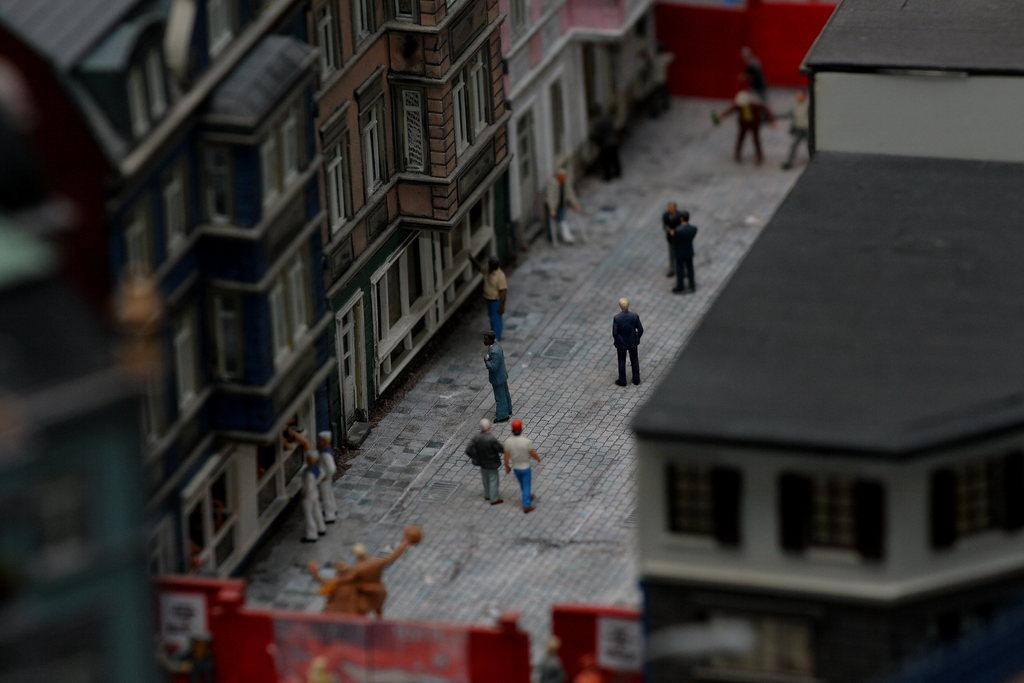What type of scene is depicted in the image? The image depicts an architectural scene. What structures can be seen in the image? There are buildings in the image. Are there any objects or figures related to play or leisure in the image? Yes, there is a toy of persons in the image. What type of pathway is present in the image? There is a road in the image. What type of barrier is present in the image? There is a wall in the image. Are there any openings or entrances in the wall? Yes, there are gates in the image. What type of bread can be seen in the image? There is no bread present in the image. Can you describe the dog that is playing with the gates in the image? There is no dog present in the image; the gates are part of the wall structure. 